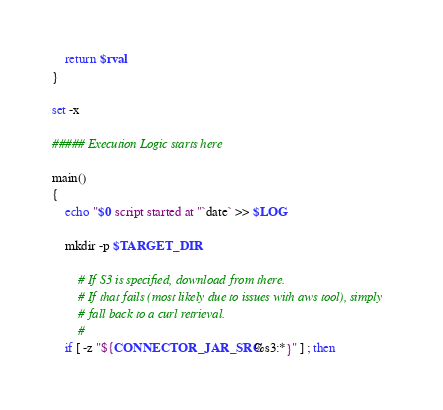<code> <loc_0><loc_0><loc_500><loc_500><_Bash_>
	return $rval
}

set -x

##### Execution Logic starts here 

main()
{
    echo "$0 script started at "`date` >> $LOG

	mkdir -p $TARGET_DIR

		# If S3 is specified, download from there.   
		# If that fails (most likely due to issues with aws tool), simply
		# fall back to a curl retrieval.
		#
	if [ -z "${CONNECTOR_JAR_SRC%s3:*}" ] ; then</code> 